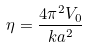Convert formula to latex. <formula><loc_0><loc_0><loc_500><loc_500>\eta = \frac { 4 \pi ^ { 2 } V _ { 0 } } { k a ^ { 2 } }</formula> 